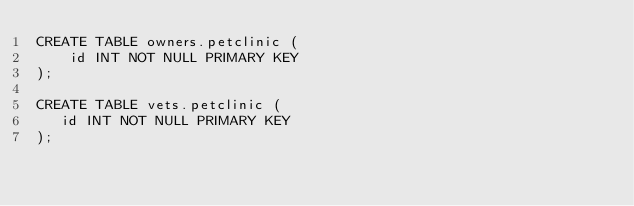Convert code to text. <code><loc_0><loc_0><loc_500><loc_500><_SQL_>CREATE TABLE owners.petclinic (
    id INT NOT NULL PRIMARY KEY
);

CREATE TABLE vets.petclinic (
   id INT NOT NULL PRIMARY KEY
);

</code> 